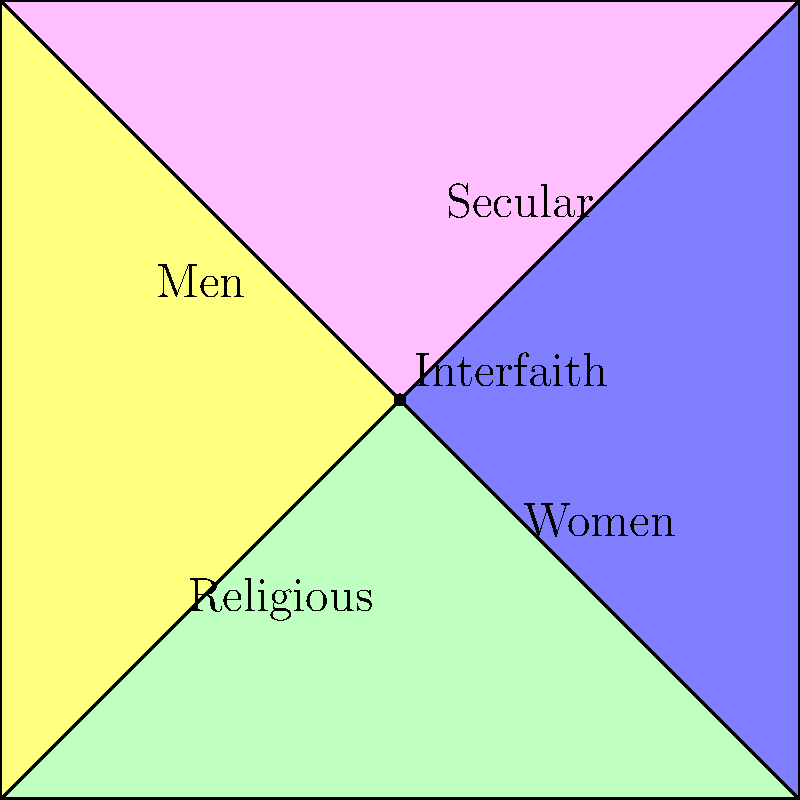In the context of promoting interfaith dialogue and women's rights, analyze the topology diagram. How many distinct social groups are represented, and what is the significance of the central point where all groups intersect? To answer this question, let's analyze the diagram step-by-step:

1. Identify the distinct social groups:
   - Green polygon: Religious
   - Blue polygon: Secular
   - Pink polygon: Men
   - Yellow polygon: Women

   There are 4 distinct social groups represented.

2. Examine the central point:
   - All four polygons intersect at a single point in the center.
   - This point is labeled "Interfaith".

3. Significance of the central point:
   a) Intersection of all groups: The central point represents a space where all four social groups converge, symbolizing potential for dialogue and interaction.
   b) Interfaith nature: The label "Interfaith" suggests this point is where different religious and secular perspectives can meet and engage in dialogue.
   c) Gender inclusivity: Both men and women are represented in this intersection, indicating a space for gender equality discussions.
   d) Bridge-building: This point serves as a potential platform for addressing women's rights issues across religious and secular boundaries.
   e) Common ground: It represents an opportunity to find shared values and concerns among diverse groups.

4. Relevance to the persona:
   As a non-Muslim religious leader advocating for women's rights and promoting interfaith dialogue, this central point is crucial. It represents the ideal space for facilitating discussions, promoting understanding, and advocating for women's rights across different social and religious contexts.
Answer: 4 groups; central point represents interfaith dialogue platform for women's rights across religious and secular contexts. 